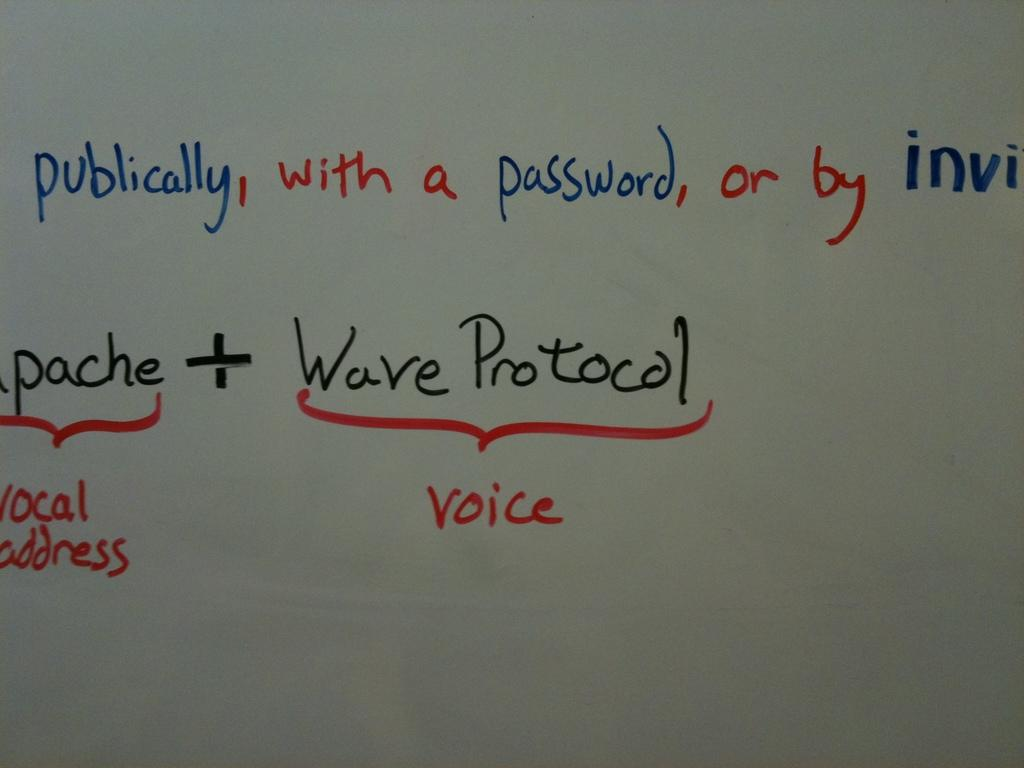<image>
Describe the image concisely. White board that contains information on waves and voice 